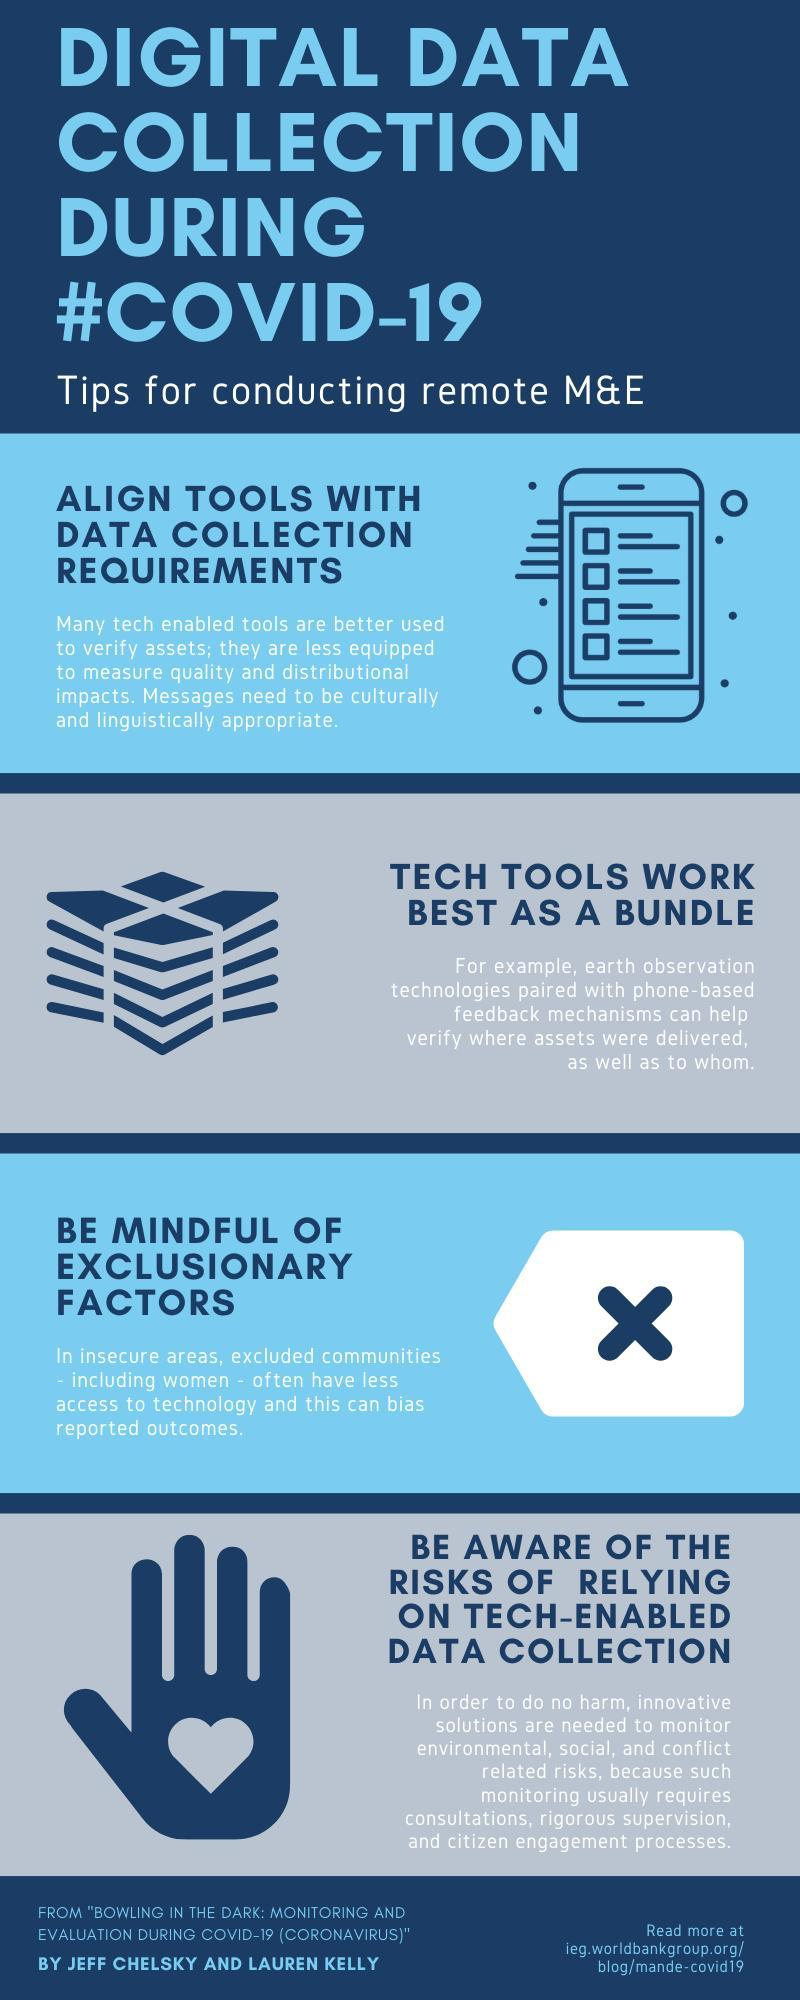Which symbol is used to represent the first tip-mobile or tv?
Answer the question with a short phrase. mobile How many tips for conducting remote M & E? 4 